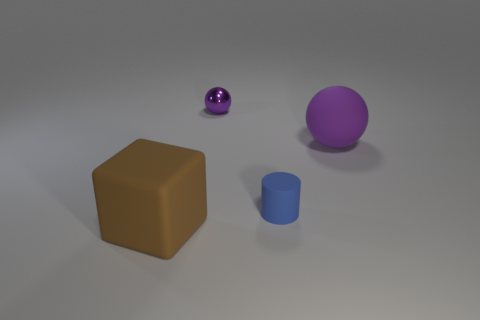Add 3 brown blocks. How many objects exist? 7 Subtract all cylinders. How many objects are left? 3 Add 2 big brown objects. How many big brown objects are left? 3 Add 1 blue objects. How many blue objects exist? 2 Subtract 2 purple balls. How many objects are left? 2 Subtract all large brown blocks. Subtract all tiny spheres. How many objects are left? 2 